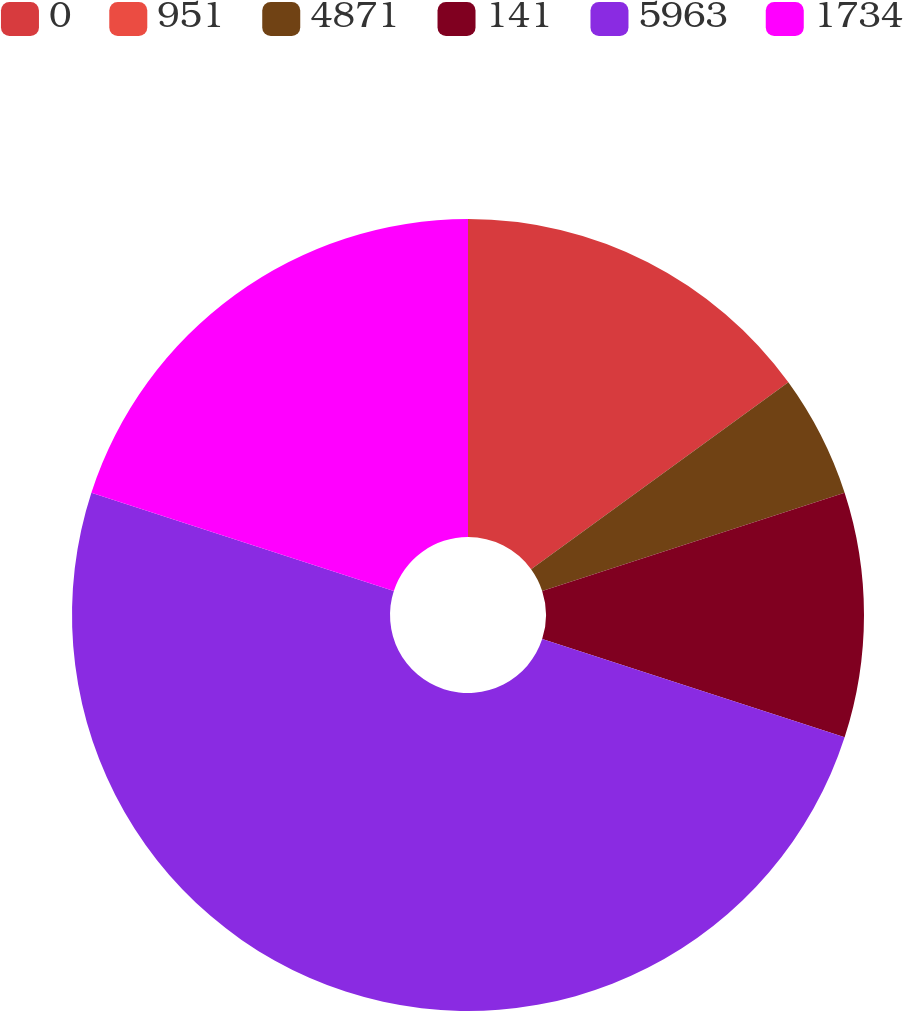Convert chart. <chart><loc_0><loc_0><loc_500><loc_500><pie_chart><fcel>0<fcel>951<fcel>4871<fcel>141<fcel>5963<fcel>1734<nl><fcel>15.0%<fcel>0.0%<fcel>5.0%<fcel>10.0%<fcel>50.0%<fcel>20.0%<nl></chart> 